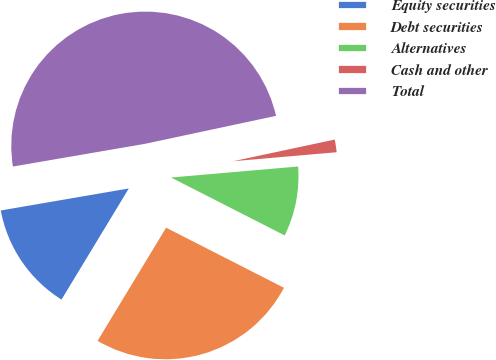Convert chart. <chart><loc_0><loc_0><loc_500><loc_500><pie_chart><fcel>Equity securities<fcel>Debt securities<fcel>Alternatives<fcel>Cash and other<fcel>Total<nl><fcel>13.62%<fcel>26.16%<fcel>8.88%<fcel>1.97%<fcel>49.36%<nl></chart> 